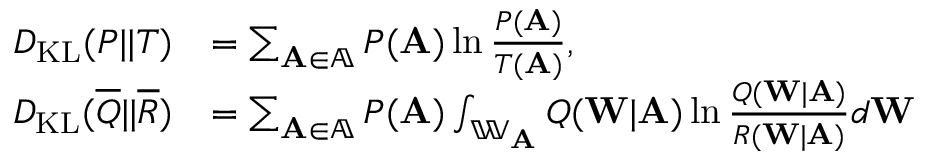Convert formula to latex. <formula><loc_0><loc_0><loc_500><loc_500>\begin{array} { r l } { D _ { K L } ( P | | T ) } & { = \sum _ { A \in \mathbb { A } } P ( A ) \ln \frac { P ( A ) } { T ( A ) } , } \\ { D _ { K L } ( \overline { Q } | | \overline { R } ) } & { = \sum _ { A \in \mathbb { A } } P ( A ) \int _ { \mathbb { W } _ { A } } Q ( W | A ) \ln \frac { Q ( W | A ) } { R ( W | A ) } d W } \end{array}</formula> 